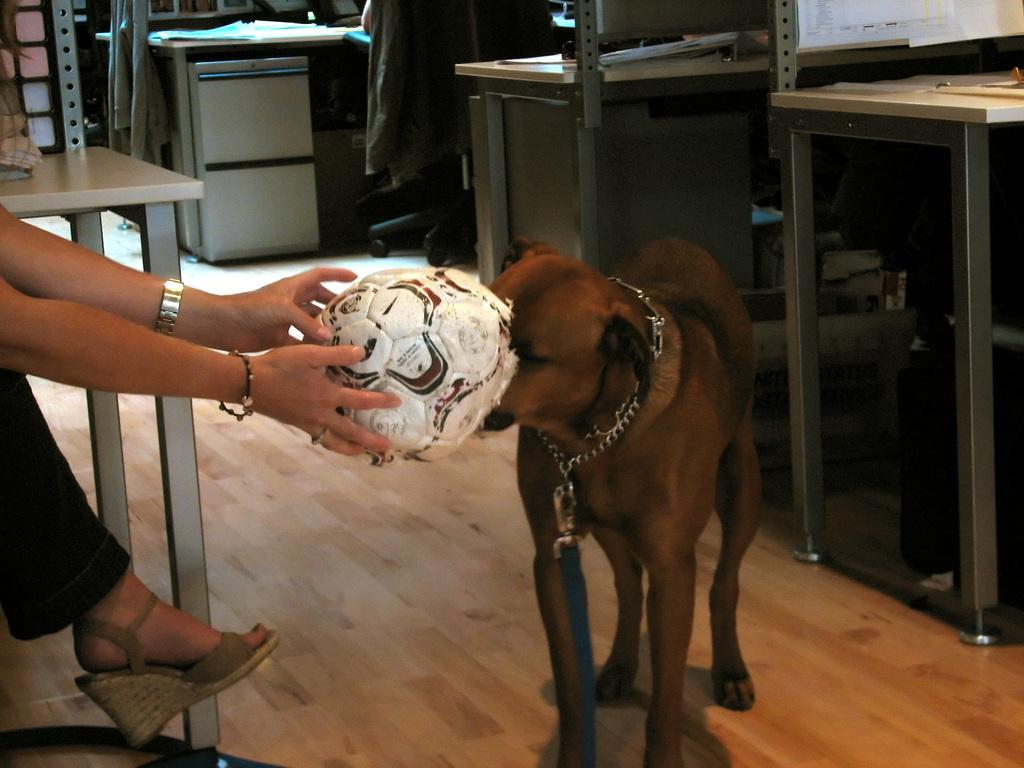What color is the dog in the image? The dog is brown in color. What is the person holding near their dog? The person is holding a ball near their dog. What type of furniture can be seen in the image? There are tables in the image. What is on top of the tables? Papers are present on the tables. Where is the jacket located in the image? The jacket is on a chair. What type of steel is used to make the cake in the image? There is no cake present in the image, so it is not possible to determine the type of steel used to make it. 